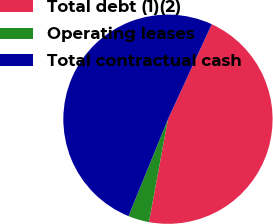Convert chart. <chart><loc_0><loc_0><loc_500><loc_500><pie_chart><fcel>Total debt (1)(2)<fcel>Operating leases<fcel>Total contractual cash<nl><fcel>46.04%<fcel>3.25%<fcel>50.71%<nl></chart> 